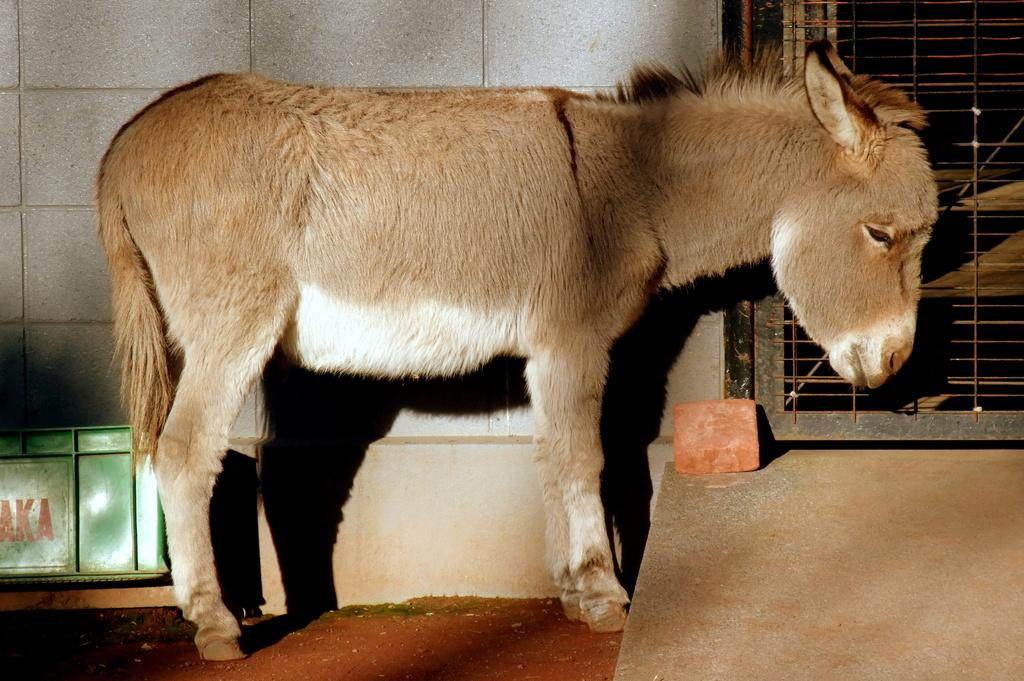What animal is present in the image? There is a donkey in the image. What object can be seen near the donkey? There is a crate in the image. What type of material is used for the bricks in the image? The bricks in the image are red in color. What can be seen in the background of the image? There is a wall and an iron gate in the background of the image. Where is the hall located in the image? There is no hall present in the image. What type of trick is the donkey performing in the image? The image does not depict the donkey performing any tricks. 